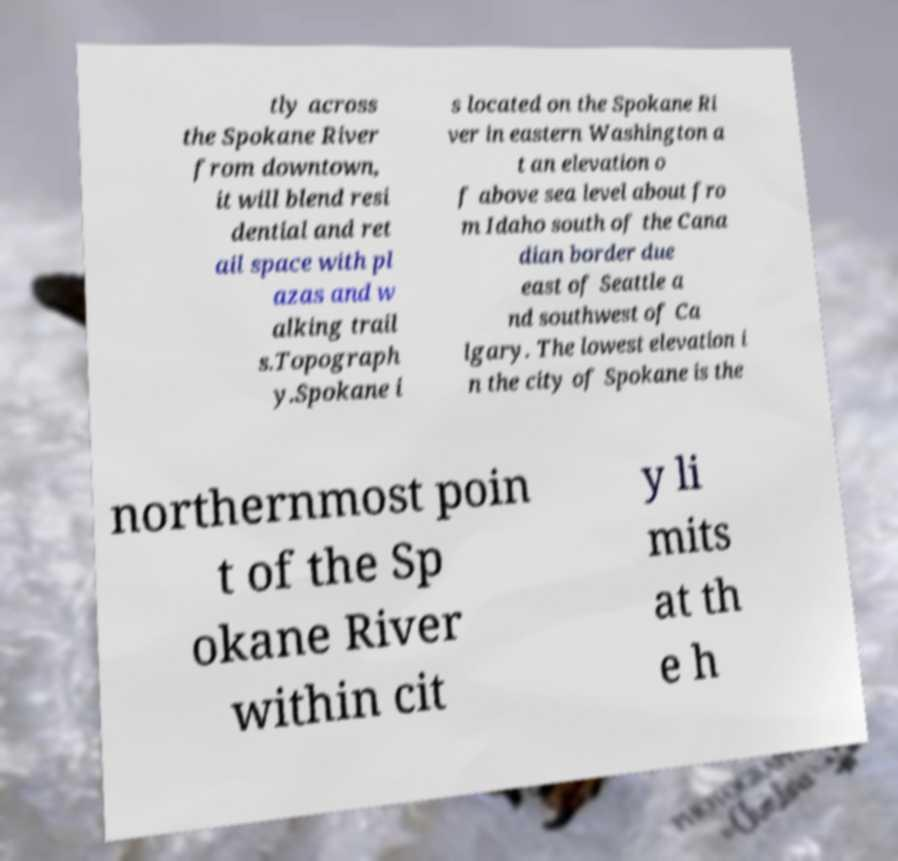Could you assist in decoding the text presented in this image and type it out clearly? tly across the Spokane River from downtown, it will blend resi dential and ret ail space with pl azas and w alking trail s.Topograph y.Spokane i s located on the Spokane Ri ver in eastern Washington a t an elevation o f above sea level about fro m Idaho south of the Cana dian border due east of Seattle a nd southwest of Ca lgary. The lowest elevation i n the city of Spokane is the northernmost poin t of the Sp okane River within cit y li mits at th e h 